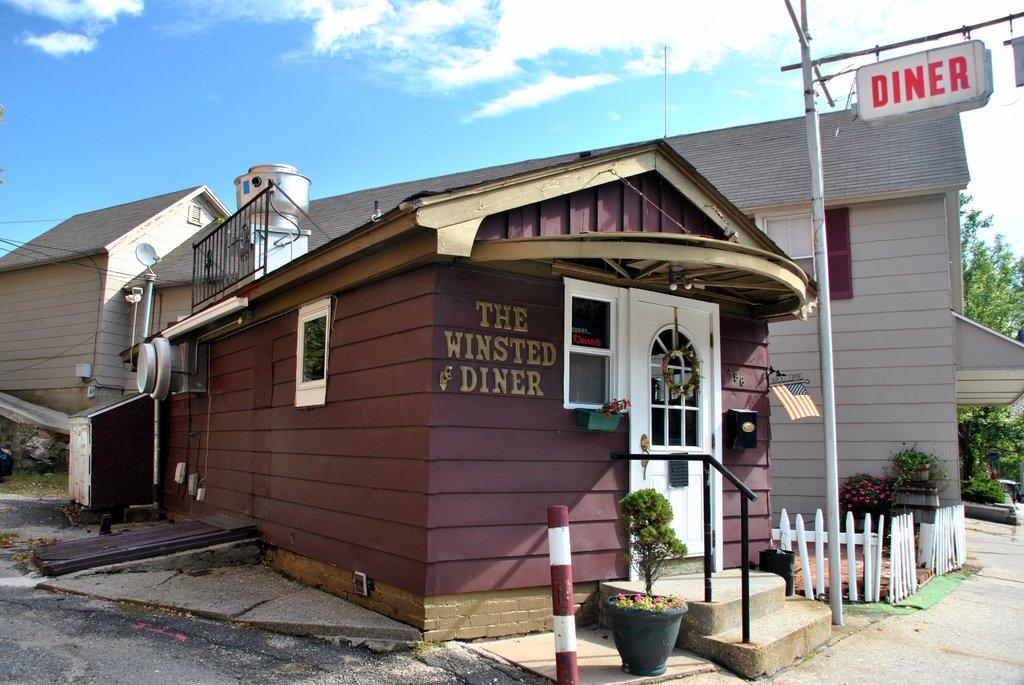What type of structure is visible in the image? There is a house in the image. What is located in front of the house? There is a flower pot in front of the house. What type of barrier is present in the image? There is a fence in the image. What other object can be seen in the image? There is a pole in the image. What is visible at the top of the image? The sky is visible at the top of the image. What type of vegetation is on the right side of the image? There are trees on the right side of the image. What type of meat is being served in the class depicted in the image? There is no class or meat present in the image; it features a house, flower pot, fence, pole, sky, and trees. 